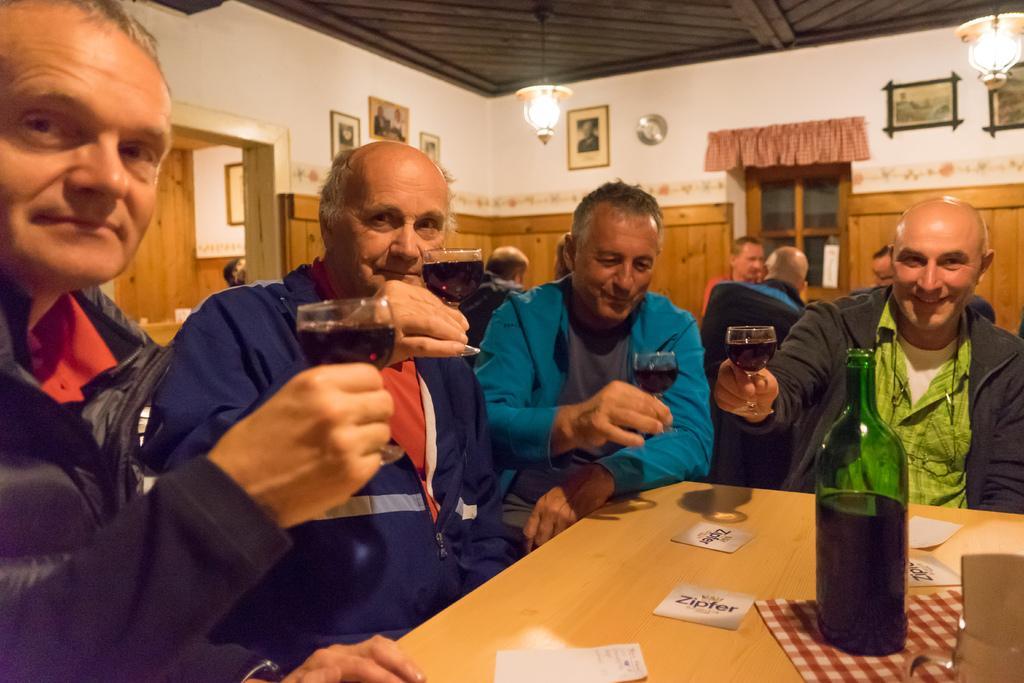Could you give a brief overview of what you see in this image? In this image few people are sitting on chairs. They are holding wine glasses. On a table there are some cards , bottle. In the background there are some paintings on the wall , there is a window, there is a door. On the roof a light is hanged. 